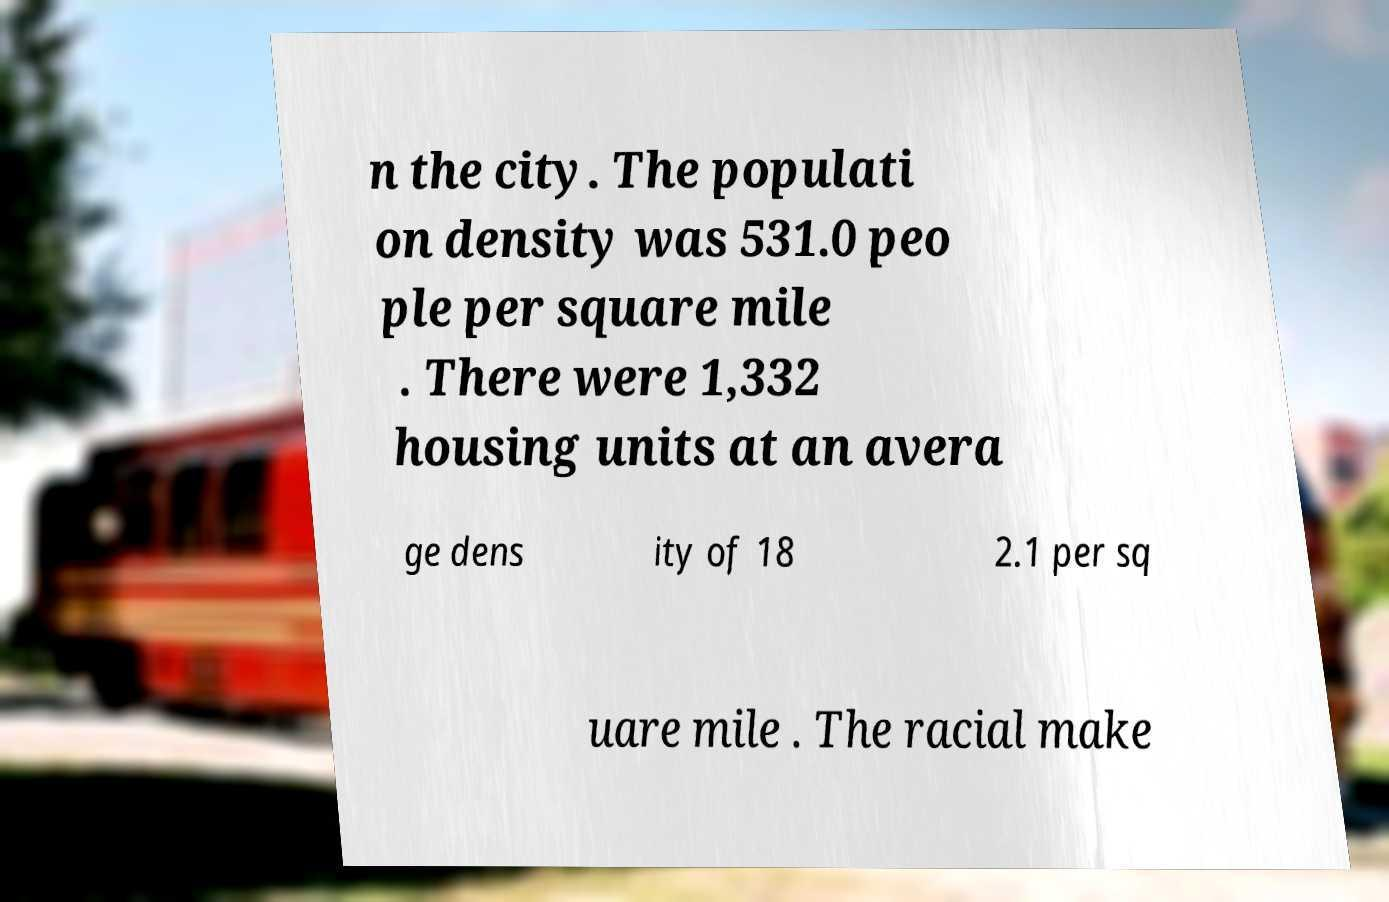Can you accurately transcribe the text from the provided image for me? n the city. The populati on density was 531.0 peo ple per square mile . There were 1,332 housing units at an avera ge dens ity of 18 2.1 per sq uare mile . The racial make 